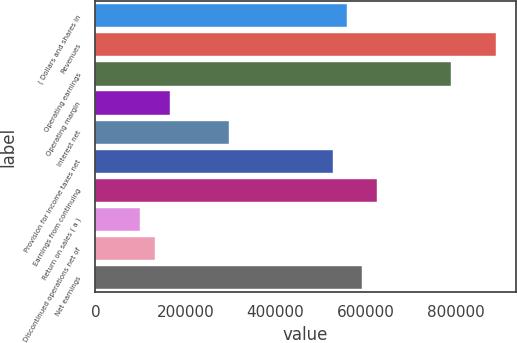<chart> <loc_0><loc_0><loc_500><loc_500><bar_chart><fcel>( Dollars and shares in<fcel>Revenues<fcel>Operating earnings<fcel>Operating margin<fcel>Interest net<fcel>Provision for income taxes net<fcel>Earnings from continuing<fcel>Return on sales ( a )<fcel>Discontinued operations net of<fcel>Net earnings<nl><fcel>559979<fcel>889378<fcel>790558<fcel>164701<fcel>296460<fcel>527039<fcel>625859<fcel>98820.8<fcel>131761<fcel>592919<nl></chart> 